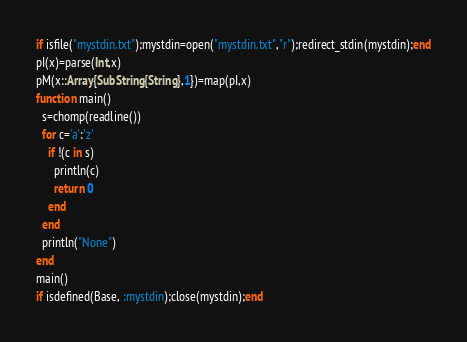Convert code to text. <code><loc_0><loc_0><loc_500><loc_500><_Julia_>if isfile("mystdin.txt");mystdin=open("mystdin.txt","r");redirect_stdin(mystdin);end
pI(x)=parse(Int,x)
pM(x::Array{SubString{String},1})=map(pI,x)
function main()
  s=chomp(readline())
  for c='a':'z'
    if !(c in s)
      println(c)
      return 0
    end
  end
  println("None")
end
main()
if isdefined(Base, :mystdin);close(mystdin);end</code> 